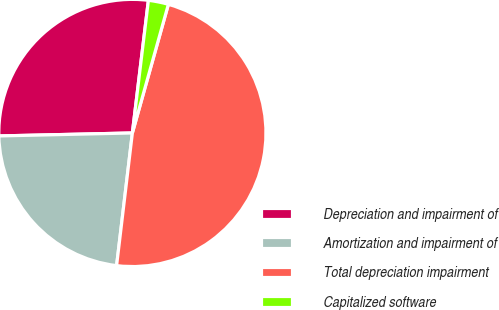Convert chart to OTSL. <chart><loc_0><loc_0><loc_500><loc_500><pie_chart><fcel>Depreciation and impairment of<fcel>Amortization and impairment of<fcel>Total depreciation impairment<fcel>Capitalized software<nl><fcel>27.27%<fcel>22.76%<fcel>47.54%<fcel>2.43%<nl></chart> 